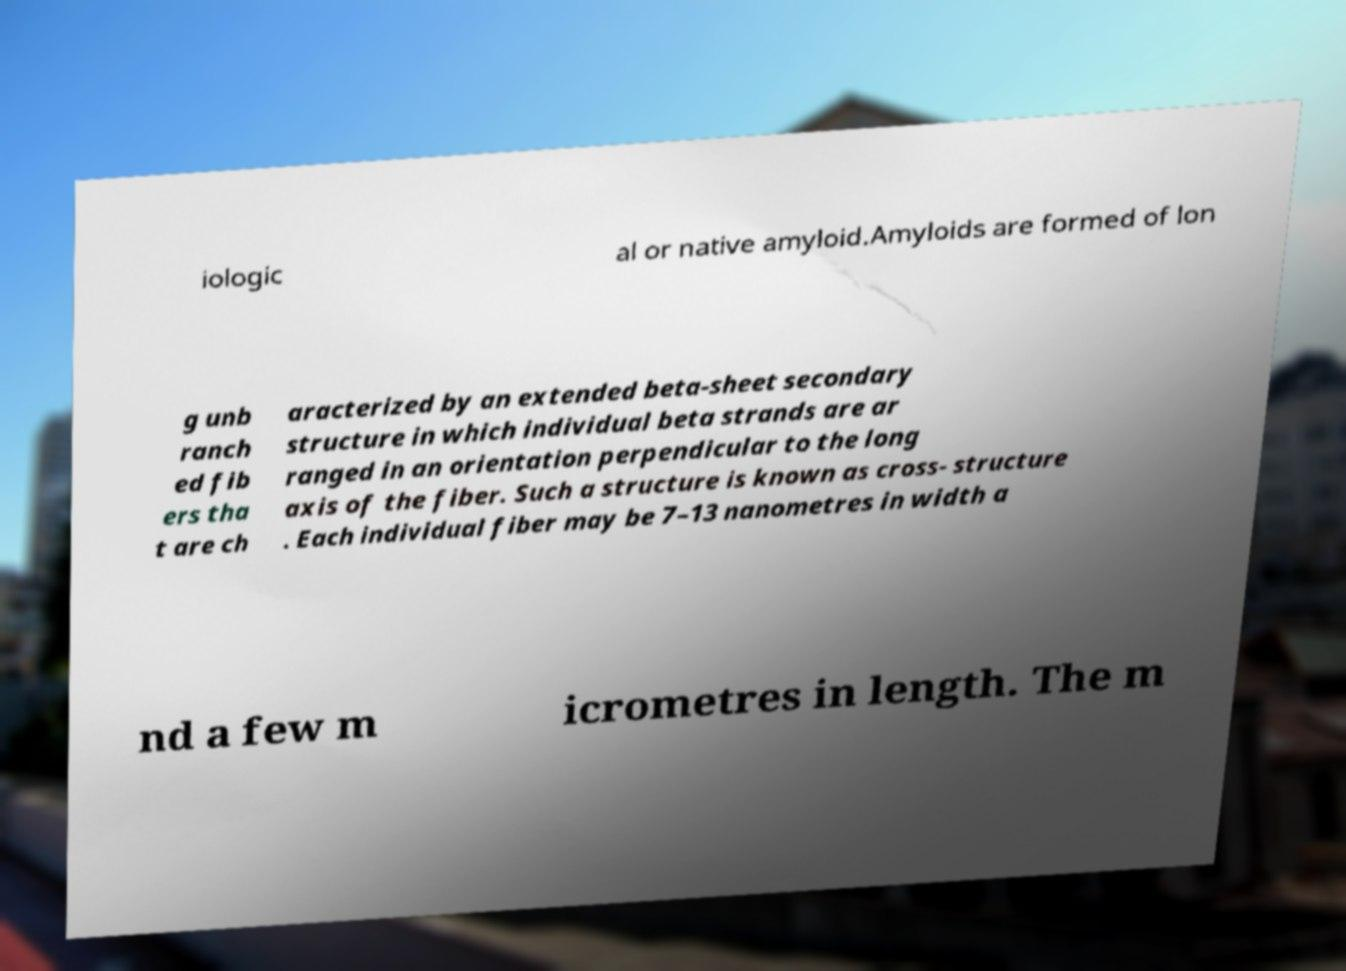For documentation purposes, I need the text within this image transcribed. Could you provide that? iologic al or native amyloid.Amyloids are formed of lon g unb ranch ed fib ers tha t are ch aracterized by an extended beta-sheet secondary structure in which individual beta strands are ar ranged in an orientation perpendicular to the long axis of the fiber. Such a structure is known as cross- structure . Each individual fiber may be 7–13 nanometres in width a nd a few m icrometres in length. The m 